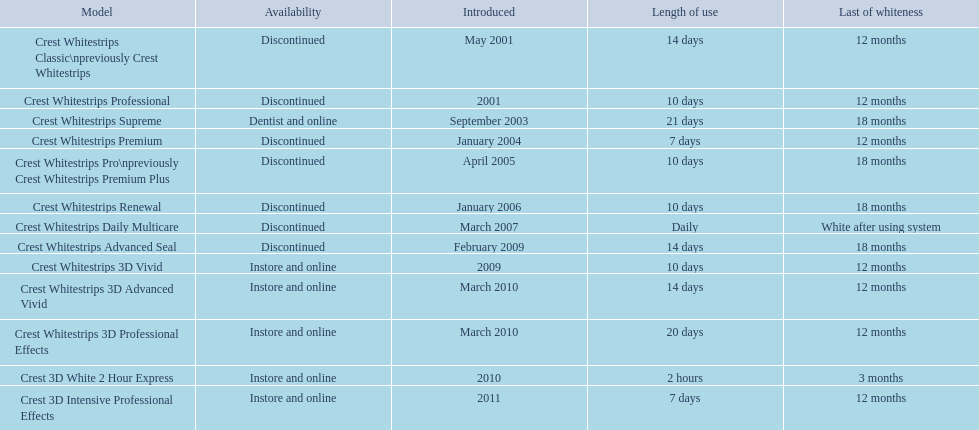What sorts of crest whitestrips have been presented? Crest Whitestrips Classic\npreviously Crest Whitestrips, Crest Whitestrips Professional, Crest Whitestrips Supreme, Crest Whitestrips Premium, Crest Whitestrips Pro\npreviously Crest Whitestrips Premium Plus, Crest Whitestrips Renewal, Crest Whitestrips Daily Multicare, Crest Whitestrips Advanced Seal, Crest Whitestrips 3D Vivid, Crest Whitestrips 3D Advanced Vivid, Crest Whitestrips 3D Professional Effects, Crest 3D White 2 Hour Express, Crest 3D Intensive Professional Effects. What was the extent of use for each sort? 14 days, 10 days, 21 days, 7 days, 10 days, 10 days, Daily, 14 days, 10 days, 14 days, 20 days, 2 hours, 7 days. And how long did each continue? 12 months, 12 months, 18 months, 12 months, 18 months, 18 months, White after using system, 18 months, 12 months, 12 months, 12 months, 3 months, 12 months. Of those models, which continued the longest with the lengthiest extent of use? Crest Whitestrips Supreme. 